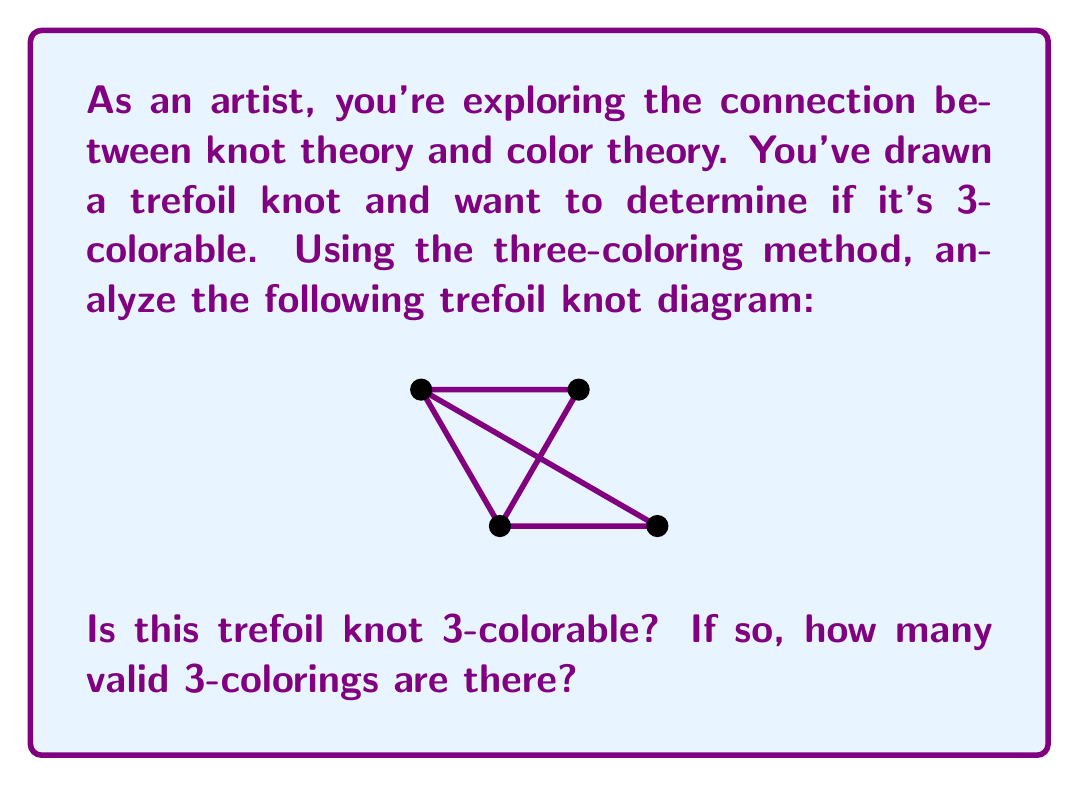Give your solution to this math problem. To determine if a knot is 3-colorable and count the number of valid 3-colorings, we follow these steps:

1) First, recall the rules for 3-coloring:
   a) Each arc must be assigned one of three colors.
   b) At each crossing, either all three colors must be present, or all arcs must have the same color.

2) For the trefoil knot, we have 3 arcs and 3 crossings.

3) Let's start by assigning a color to one arc. We have 3 choices for this.

4) At the first crossing, we must use either the same color or both remaining colors. If we use the same color, all arcs will be the same color, which is a valid coloring.

5) If we use different colors, we have only one way to color the remaining two arcs to satisfy the crossing condition.

6) This coloring will automatically satisfy the conditions at the other two crossings due to the symmetry of the trefoil knot.

7) Therefore, we have:
   - 3 colorings where all arcs are the same color (one for each color)
   - 6 colorings where all three colors are used (2 ways for each initial color choice)

8) In total, we have 3 + 6 = 9 valid 3-colorings.

Thus, the trefoil knot is 3-colorable, and there are 9 valid 3-colorings.
Answer: Yes; 9 valid 3-colorings 